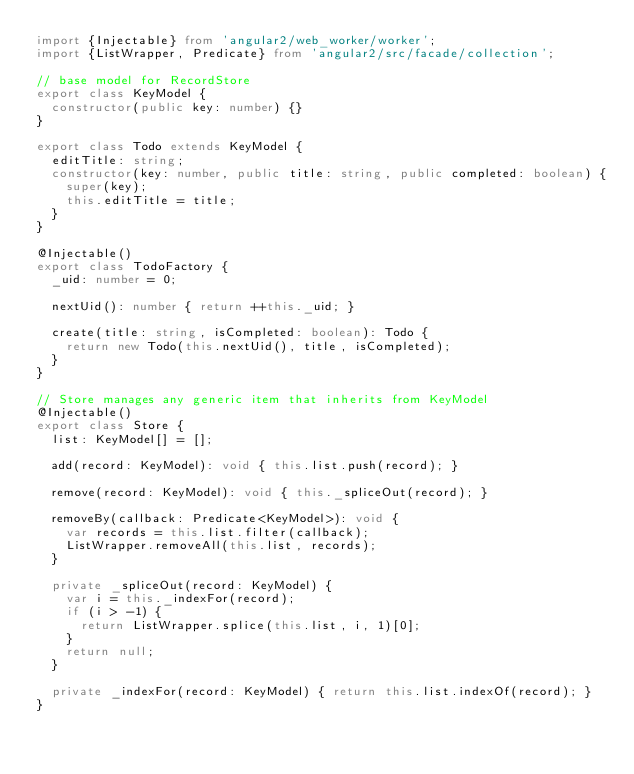Convert code to text. <code><loc_0><loc_0><loc_500><loc_500><_TypeScript_>import {Injectable} from 'angular2/web_worker/worker';
import {ListWrapper, Predicate} from 'angular2/src/facade/collection';

// base model for RecordStore
export class KeyModel {
  constructor(public key: number) {}
}

export class Todo extends KeyModel {
  editTitle: string;
  constructor(key: number, public title: string, public completed: boolean) {
    super(key);
    this.editTitle = title;
  }
}

@Injectable()
export class TodoFactory {
  _uid: number = 0;

  nextUid(): number { return ++this._uid; }

  create(title: string, isCompleted: boolean): Todo {
    return new Todo(this.nextUid(), title, isCompleted);
  }
}

// Store manages any generic item that inherits from KeyModel
@Injectable()
export class Store {
  list: KeyModel[] = [];

  add(record: KeyModel): void { this.list.push(record); }

  remove(record: KeyModel): void { this._spliceOut(record); }

  removeBy(callback: Predicate<KeyModel>): void {
    var records = this.list.filter(callback);
    ListWrapper.removeAll(this.list, records);
  }

  private _spliceOut(record: KeyModel) {
    var i = this._indexFor(record);
    if (i > -1) {
      return ListWrapper.splice(this.list, i, 1)[0];
    }
    return null;
  }

  private _indexFor(record: KeyModel) { return this.list.indexOf(record); }
}
</code> 